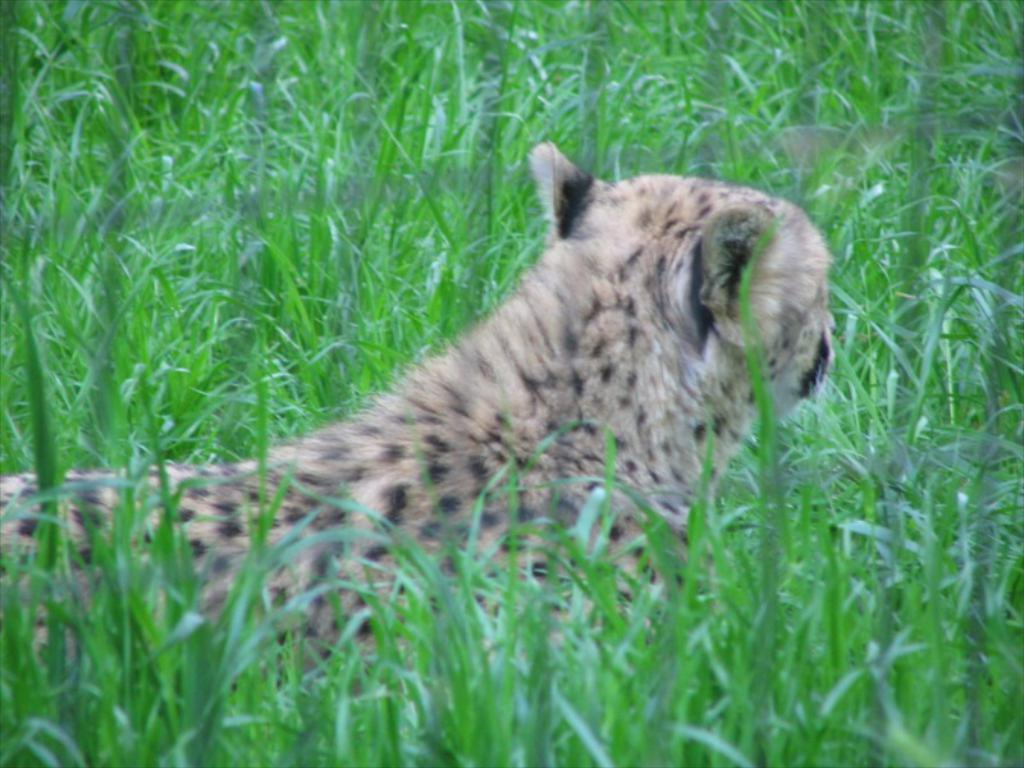What type of creature can be seen in the image? There is an animal in the image. Where is the animal located? The animal is on the ground. What can be seen in the background of the image? There is grass visible in the background of the image. What type of record can be seen in the animal's paw in the image? There is no record present in the image, and the animal's paw is not shown holding anything. 